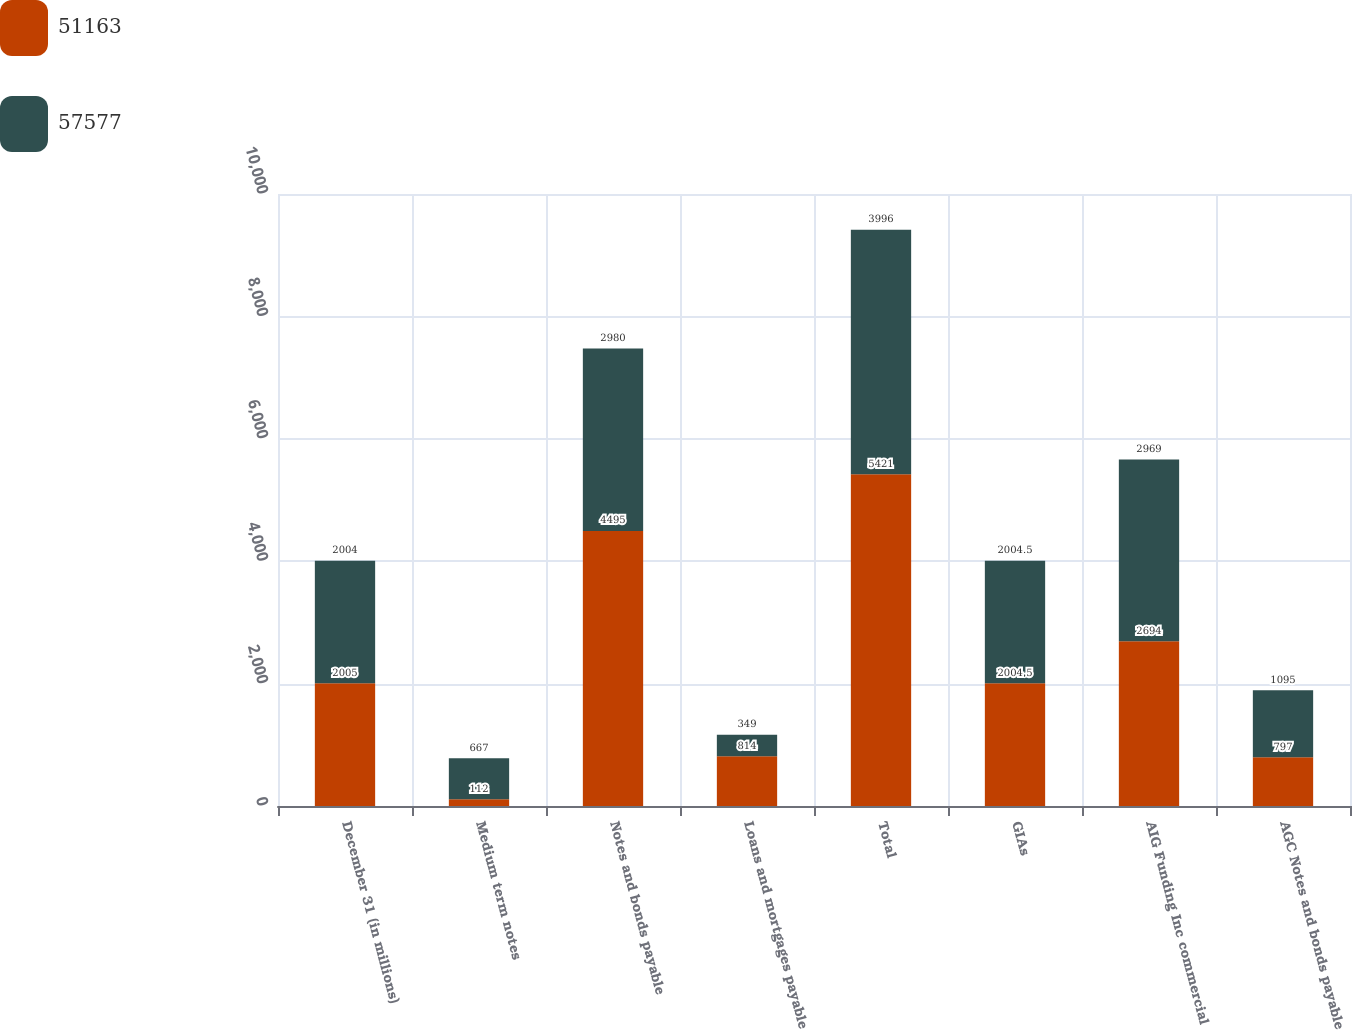Convert chart to OTSL. <chart><loc_0><loc_0><loc_500><loc_500><stacked_bar_chart><ecel><fcel>December 31 (in millions)<fcel>Medium term notes<fcel>Notes and bonds payable<fcel>Loans and mortgages payable<fcel>Total<fcel>GIAs<fcel>AIG Funding Inc commercial<fcel>AGC Notes and bonds payable<nl><fcel>51163<fcel>2005<fcel>112<fcel>4495<fcel>814<fcel>5421<fcel>2004.5<fcel>2694<fcel>797<nl><fcel>57577<fcel>2004<fcel>667<fcel>2980<fcel>349<fcel>3996<fcel>2004.5<fcel>2969<fcel>1095<nl></chart> 